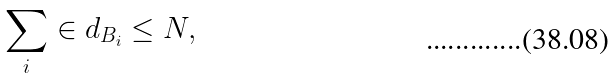Convert formula to latex. <formula><loc_0><loc_0><loc_500><loc_500>\sum _ { i } \in d _ { B _ { i } } \leq N ,</formula> 